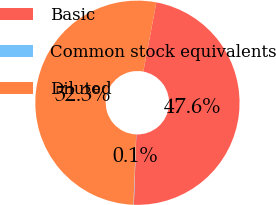Convert chart to OTSL. <chart><loc_0><loc_0><loc_500><loc_500><pie_chart><fcel>Basic<fcel>Common stock equivalents<fcel>Diluted<nl><fcel>47.59%<fcel>0.07%<fcel>52.35%<nl></chart> 